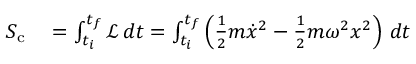<formula> <loc_0><loc_0><loc_500><loc_500>\begin{array} { r l } { S _ { c } } & = \int _ { t _ { i } } ^ { t _ { f } } { \mathcal { L } } \, d t = \int _ { t _ { i } } ^ { t _ { f } } \left ( { \frac { 1 } { 2 } } m { \dot { x } } ^ { 2 } - { \frac { 1 } { 2 } } m \omega ^ { 2 } x ^ { 2 } \right ) \, d t } \end{array}</formula> 